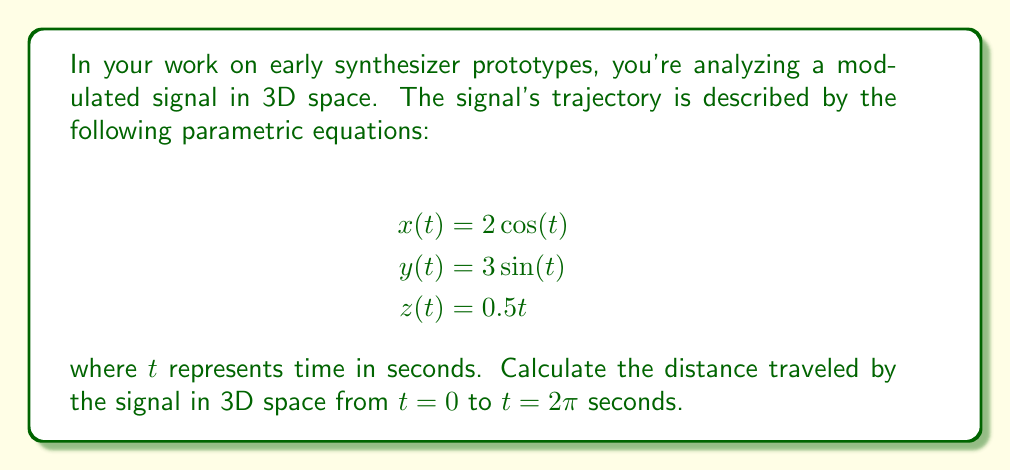Help me with this question. To solve this problem, we need to follow these steps:

1) The distance traveled along a 3D parametric curve is given by the arc length formula:

   $$L = \int_a^b \sqrt{\left(\frac{dx}{dt}\right)^2 + \left(\frac{dy}{dt}\right)^2 + \left(\frac{dz}{dt}\right)^2} dt$$

2) First, let's find the derivatives:
   
   $$\frac{dx}{dt} = -2\sin(t)$$
   $$\frac{dy}{dt} = 3\cos(t)$$
   $$\frac{dz}{dt} = 0.5$$

3) Now, let's substitute these into the arc length formula:

   $$L = \int_0^{2\pi} \sqrt{(-2\sin(t))^2 + (3\cos(t))^2 + (0.5)^2} dt$$

4) Simplify under the square root:

   $$L = \int_0^{2\pi} \sqrt{4\sin^2(t) + 9\cos^2(t) + 0.25} dt$$

5) Use the trigonometric identity $\sin^2(t) + \cos^2(t) = 1$:

   $$L = \int_0^{2\pi} \sqrt{4(1-\cos^2(t)) + 9\cos^2(t) + 0.25} dt$$
   $$L = \int_0^{2\pi} \sqrt{4 - 4\cos^2(t) + 9\cos^2(t) + 0.25} dt$$
   $$L = \int_0^{2\pi} \sqrt{5\cos^2(t) + 4.25} dt$$

6) This integral doesn't have an elementary antiderivative. We need to evaluate it numerically. Using a numerical integration method (like Simpson's rule or a computer algebra system), we get:

   $$L \approx 13.3649$$

Therefore, the distance traveled by the signal in 3D space from $t=0$ to $t=2\pi$ seconds is approximately 13.3649 units.
Answer: The distance traveled by the signal is approximately 13.3649 units. 